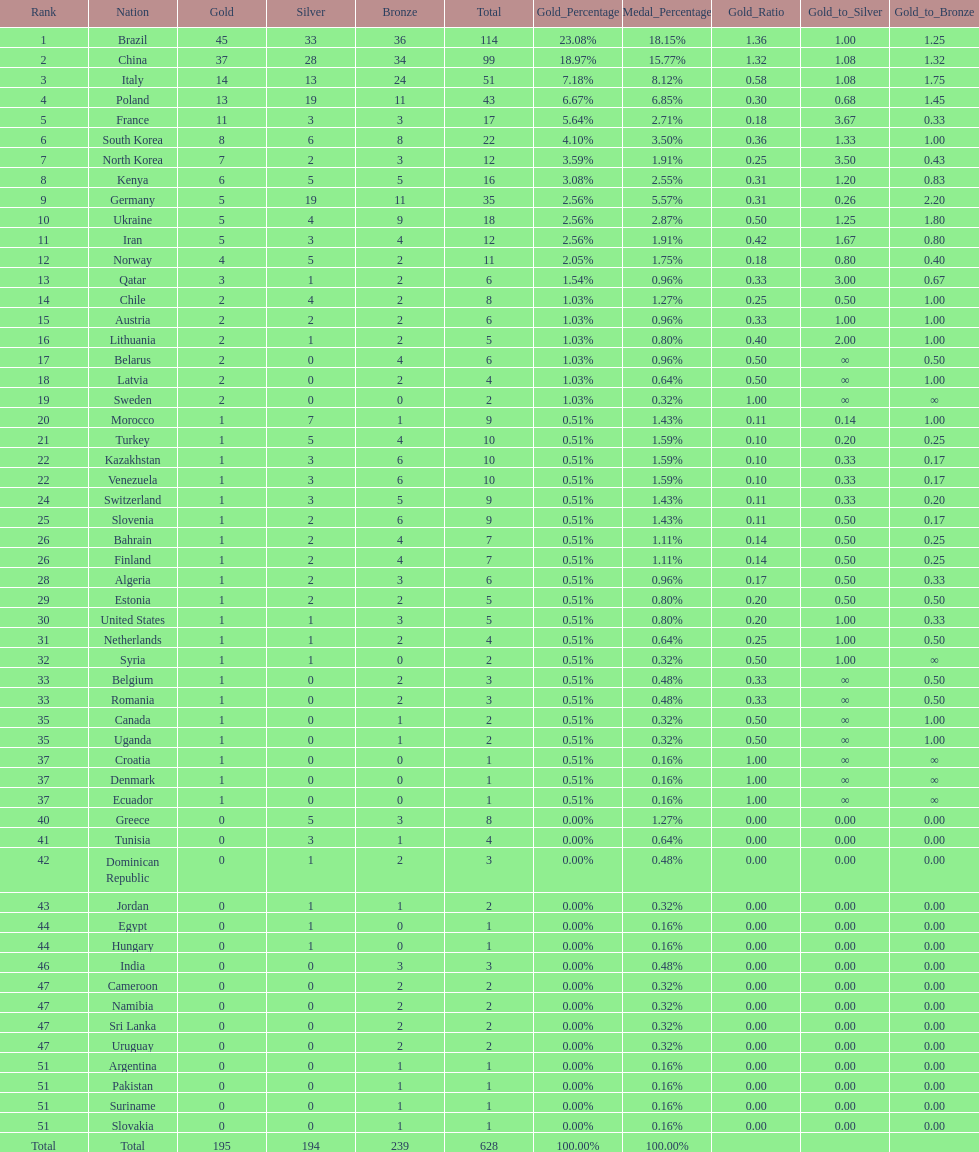Which nation earned the most gold medals? Brazil. 